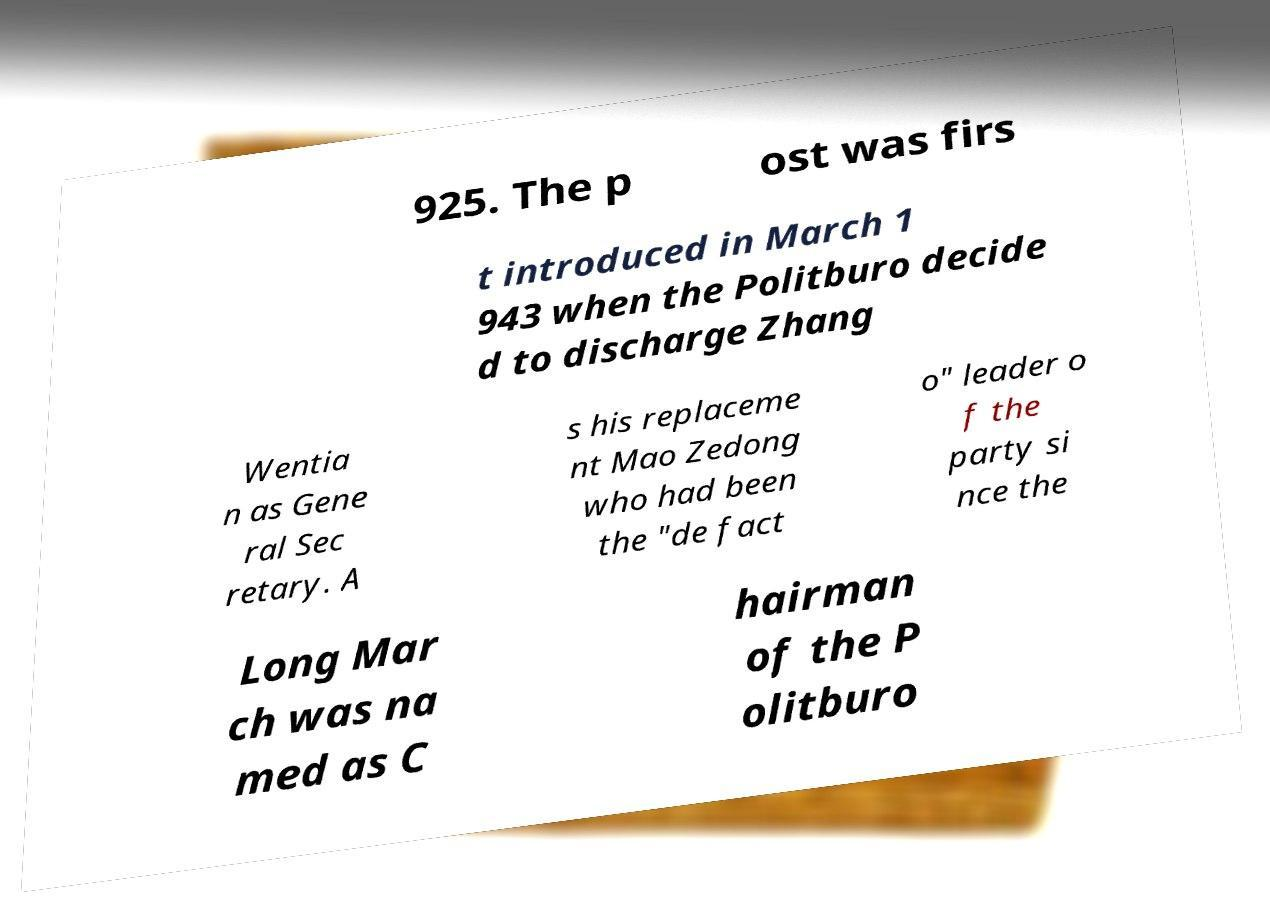Can you read and provide the text displayed in the image?This photo seems to have some interesting text. Can you extract and type it out for me? 925. The p ost was firs t introduced in March 1 943 when the Politburo decide d to discharge Zhang Wentia n as Gene ral Sec retary. A s his replaceme nt Mao Zedong who had been the "de fact o" leader o f the party si nce the Long Mar ch was na med as C hairman of the P olitburo 